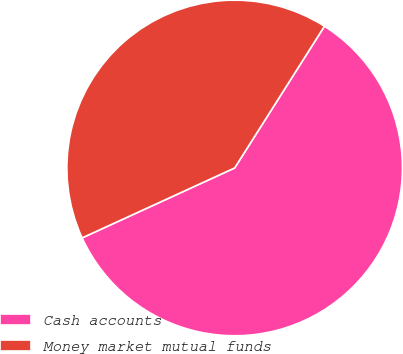Convert chart. <chart><loc_0><loc_0><loc_500><loc_500><pie_chart><fcel>Cash accounts<fcel>Money market mutual funds<nl><fcel>59.17%<fcel>40.83%<nl></chart> 